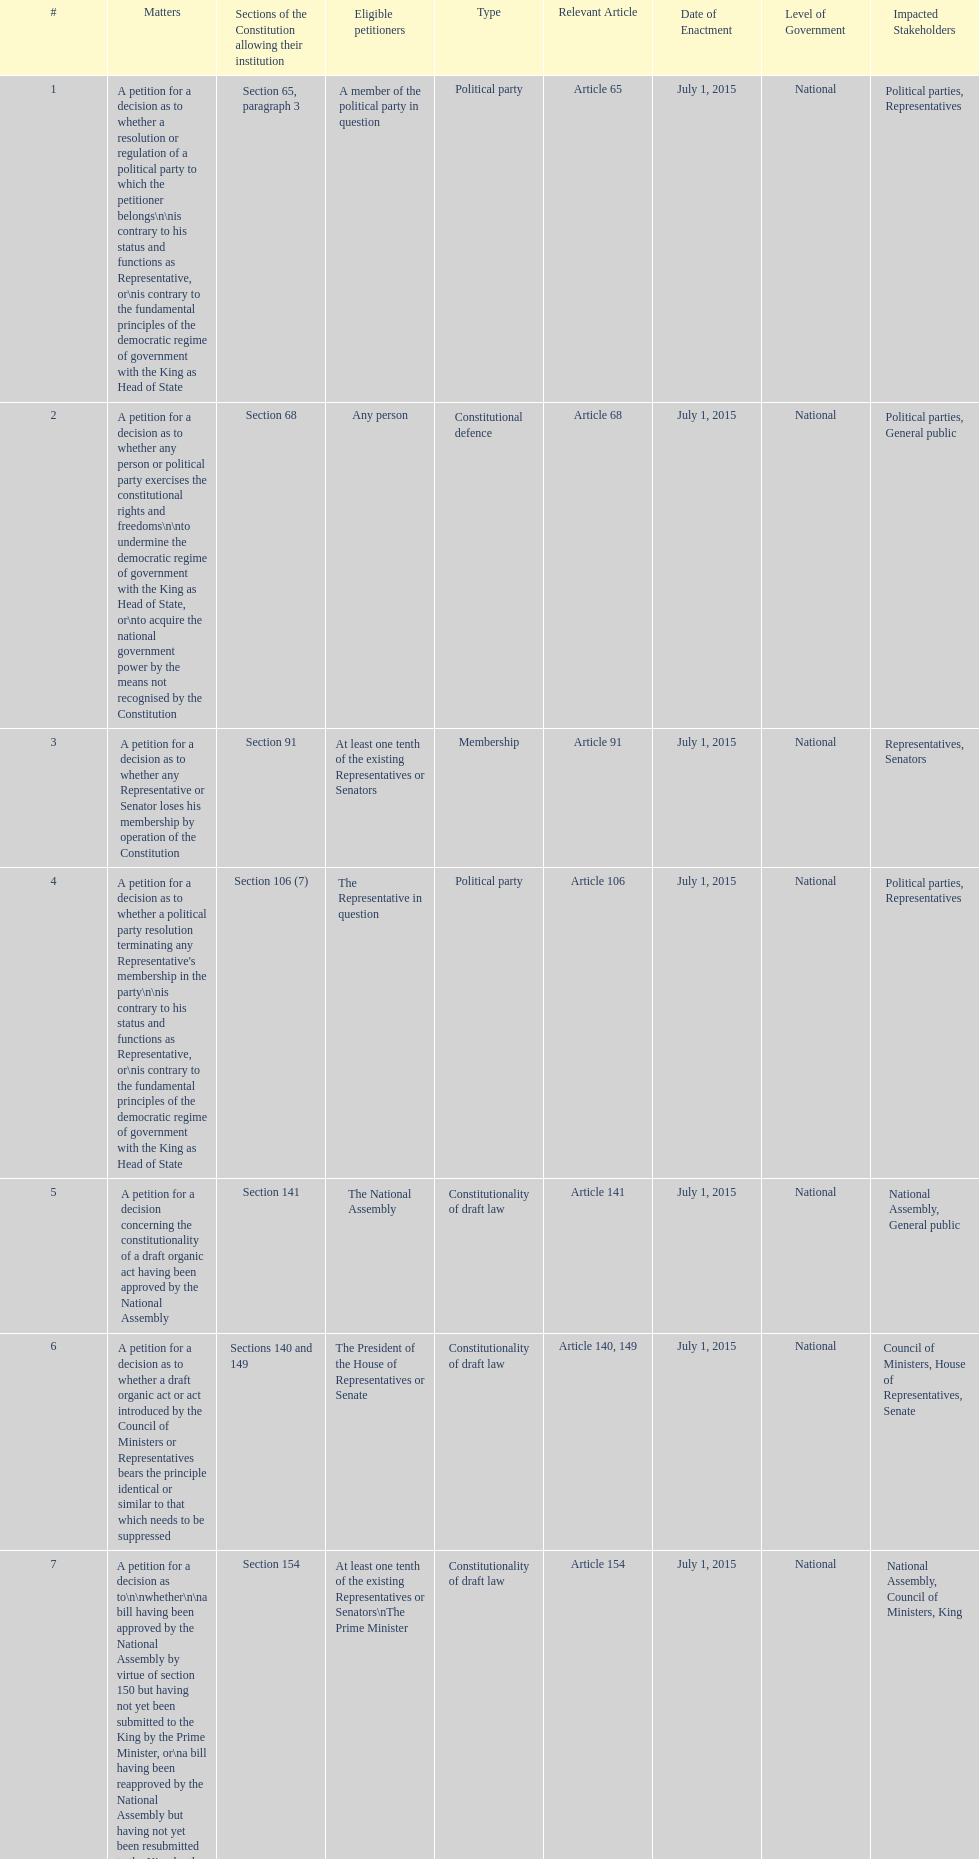How many matters require at least one tenth of the existing representatives or senators? 7. 